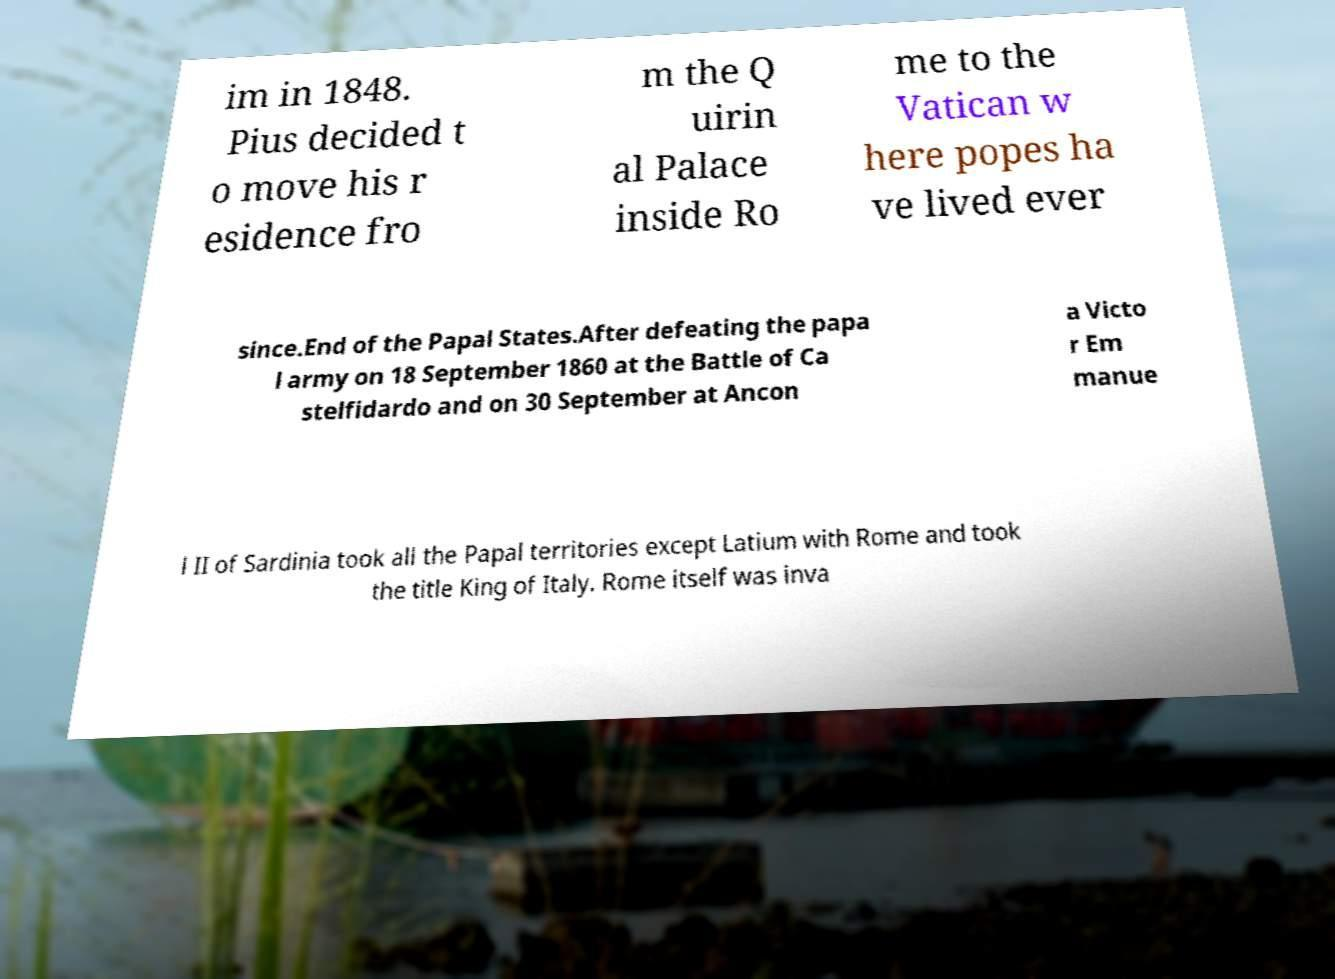Could you assist in decoding the text presented in this image and type it out clearly? im in 1848. Pius decided t o move his r esidence fro m the Q uirin al Palace inside Ro me to the Vatican w here popes ha ve lived ever since.End of the Papal States.After defeating the papa l army on 18 September 1860 at the Battle of Ca stelfidardo and on 30 September at Ancon a Victo r Em manue l II of Sardinia took all the Papal territories except Latium with Rome and took the title King of Italy. Rome itself was inva 